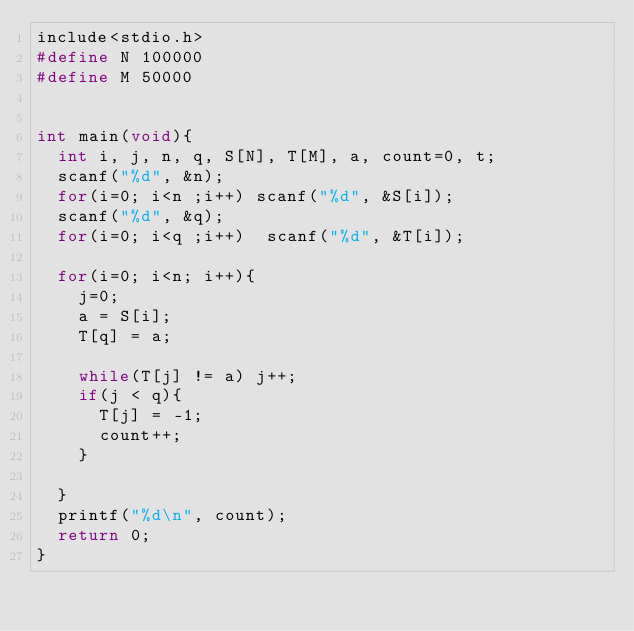Convert code to text. <code><loc_0><loc_0><loc_500><loc_500><_C_>include<stdio.h>
#define N 100000
#define M 50000


int main(void){
  int i, j, n, q, S[N], T[M], a, count=0, t;
  scanf("%d", &n);
  for(i=0; i<n ;i++) scanf("%d", &S[i]);
  scanf("%d", &q);
  for(i=0; i<q ;i++)  scanf("%d", &T[i]);
  
  for(i=0; i<n; i++){
    j=0;
    a = S[i];
    T[q] = a;

    while(T[j] != a) j++;
    if(j < q){
      T[j] = -1;
      count++;
    }

  }
  printf("%d\n", count);
  return 0;
}</code> 